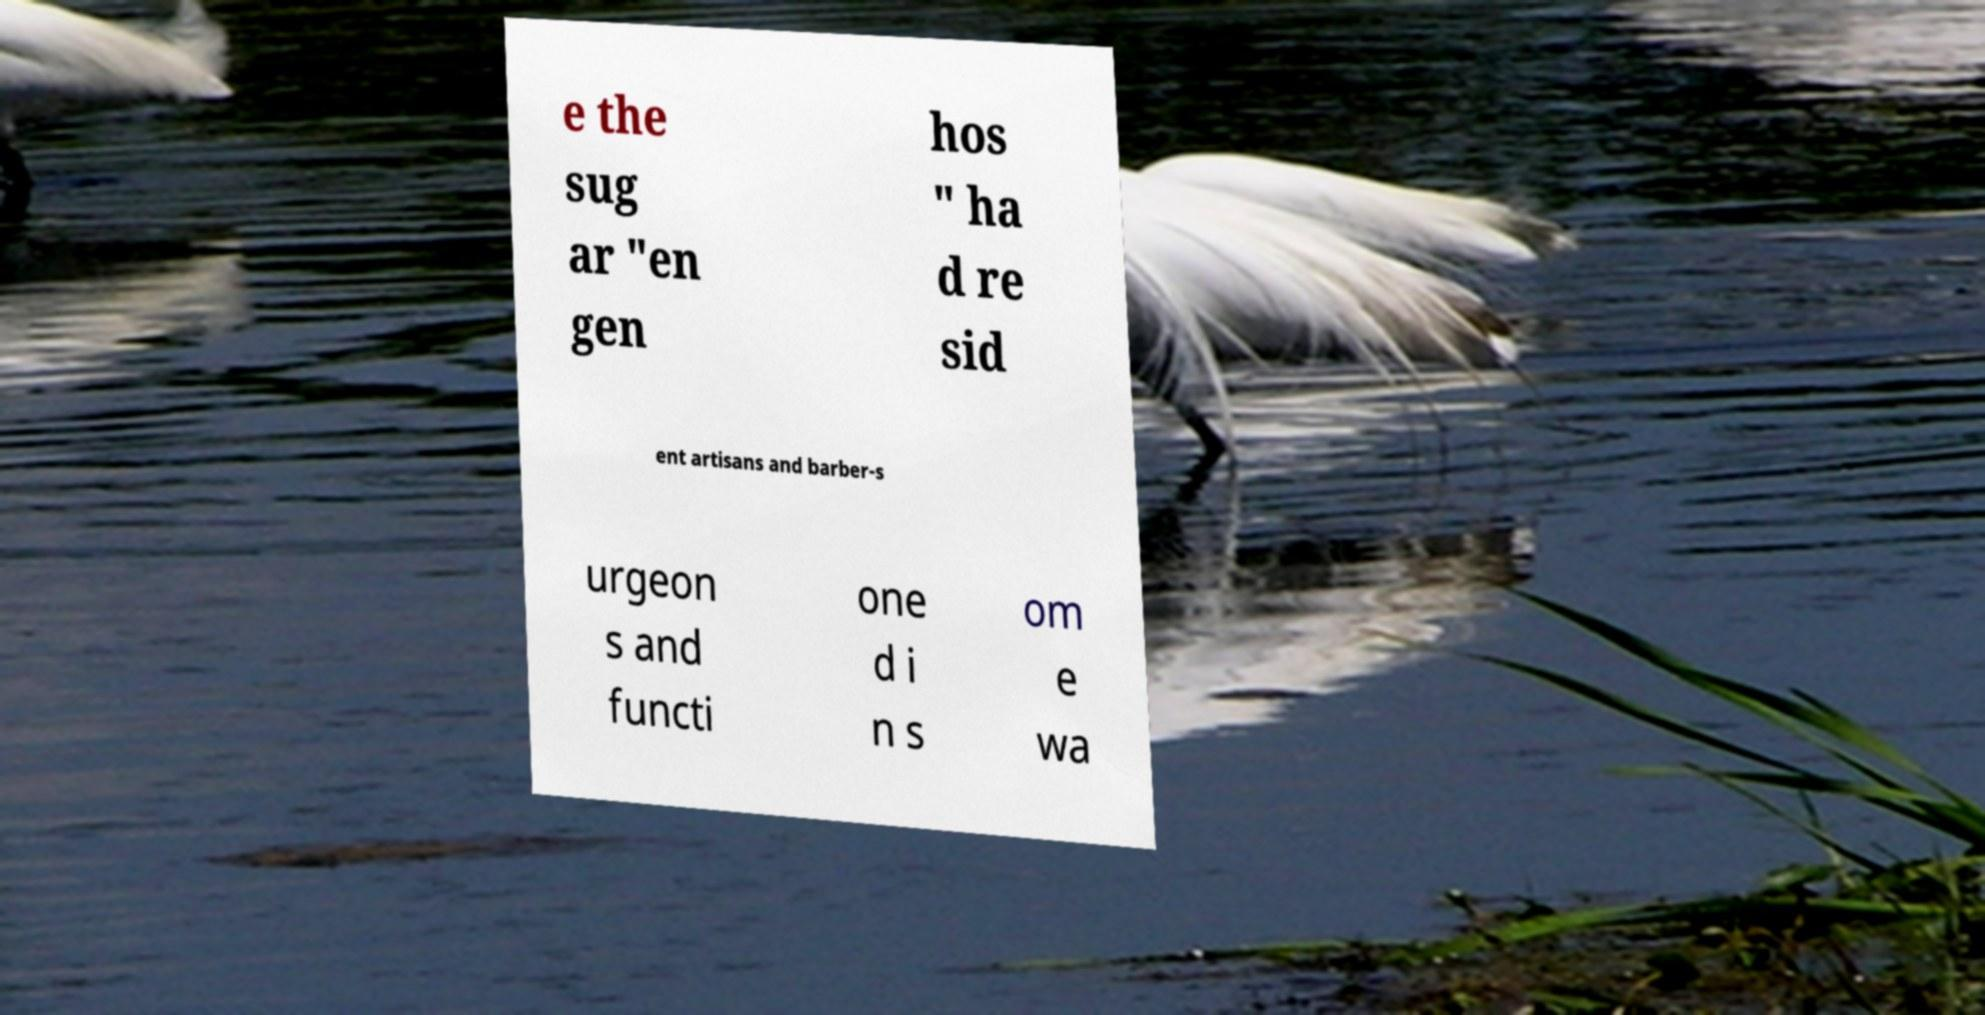Please read and relay the text visible in this image. What does it say? e the sug ar "en gen hos " ha d re sid ent artisans and barber-s urgeon s and functi one d i n s om e wa 